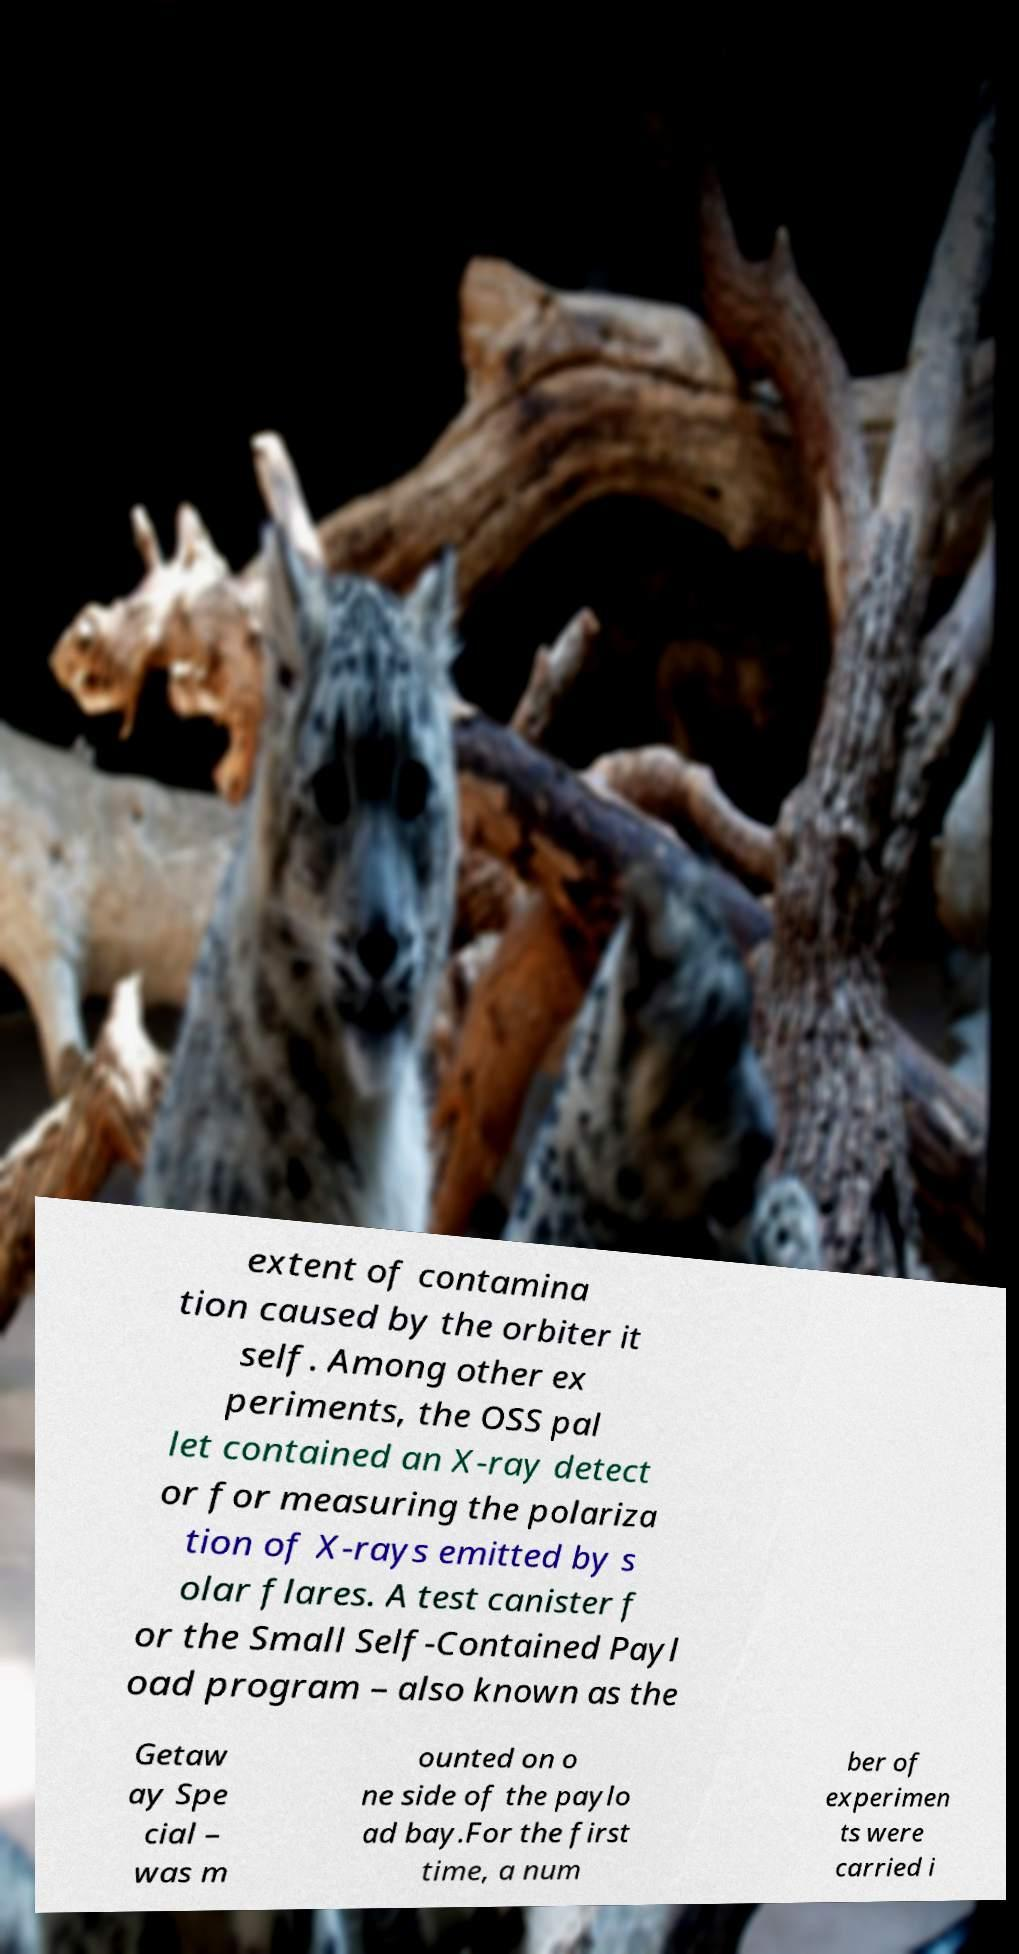What messages or text are displayed in this image? I need them in a readable, typed format. extent of contamina tion caused by the orbiter it self. Among other ex periments, the OSS pal let contained an X-ray detect or for measuring the polariza tion of X-rays emitted by s olar flares. A test canister f or the Small Self-Contained Payl oad program – also known as the Getaw ay Spe cial – was m ounted on o ne side of the paylo ad bay.For the first time, a num ber of experimen ts were carried i 